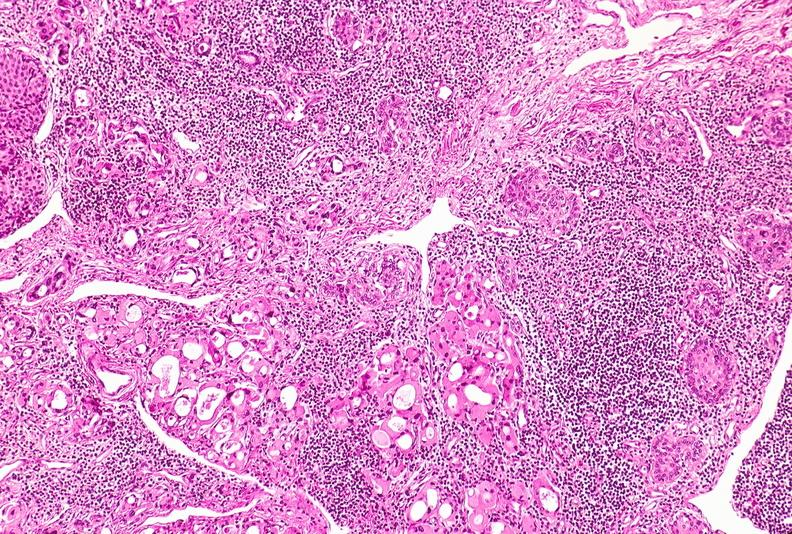what is present?
Answer the question using a single word or phrase. Endocrine 